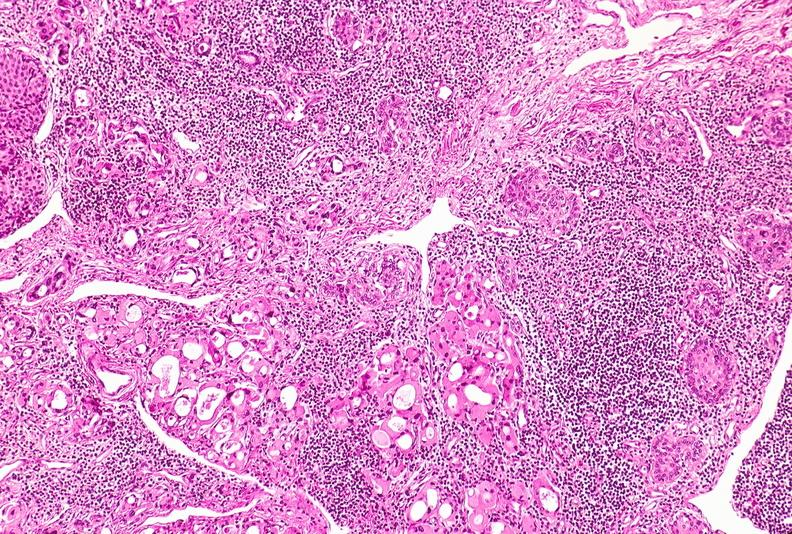what is present?
Answer the question using a single word or phrase. Endocrine 